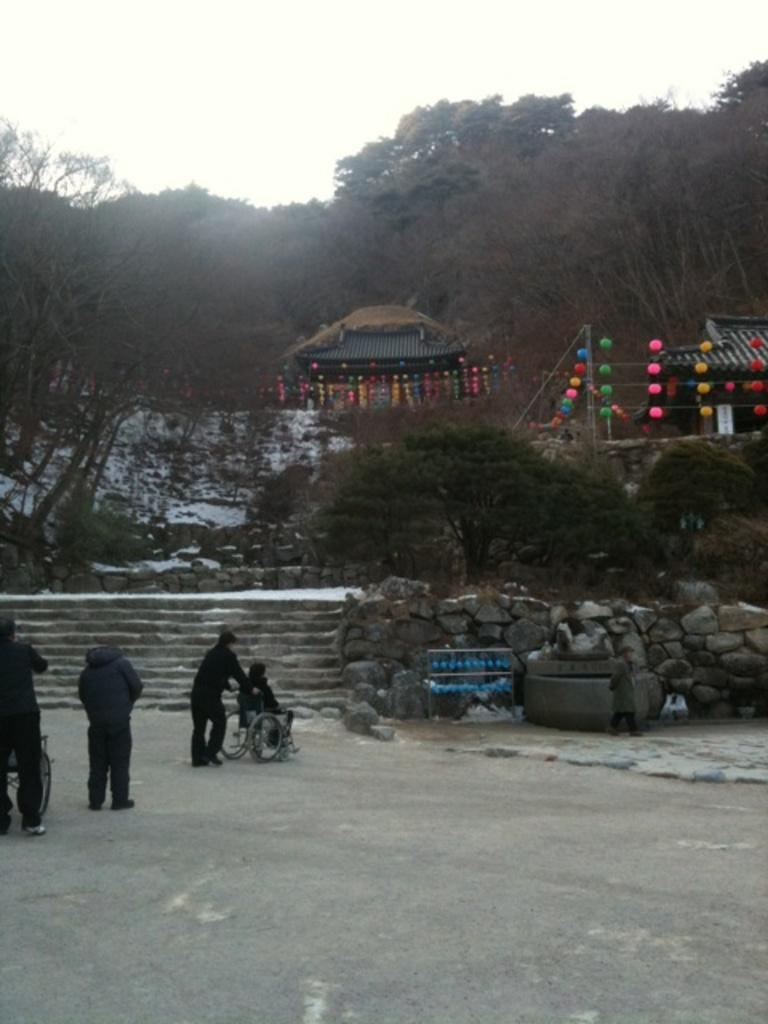Who or what can be seen in the image? There are persons in the image. What is the primary feature of the landscape in the image? There is a road in the image. What type of natural environment is visible in the background of the image? There are trees in the background of the image. What type of structures are visible in the background of the image? There are huts in the background of the image. What additional decorative elements can be seen in the background of the image? Decorative items are present in the background of the image. What is visible above the landscape in the image? The sky is visible in the background of the image. How many dolls can be seen on the ground in the image? There are no dolls present in the image. What type of ground is visible in the image? The ground is not explicitly mentioned in the provided facts, but it can be inferred that there is a road, which suggests a paved surface. 